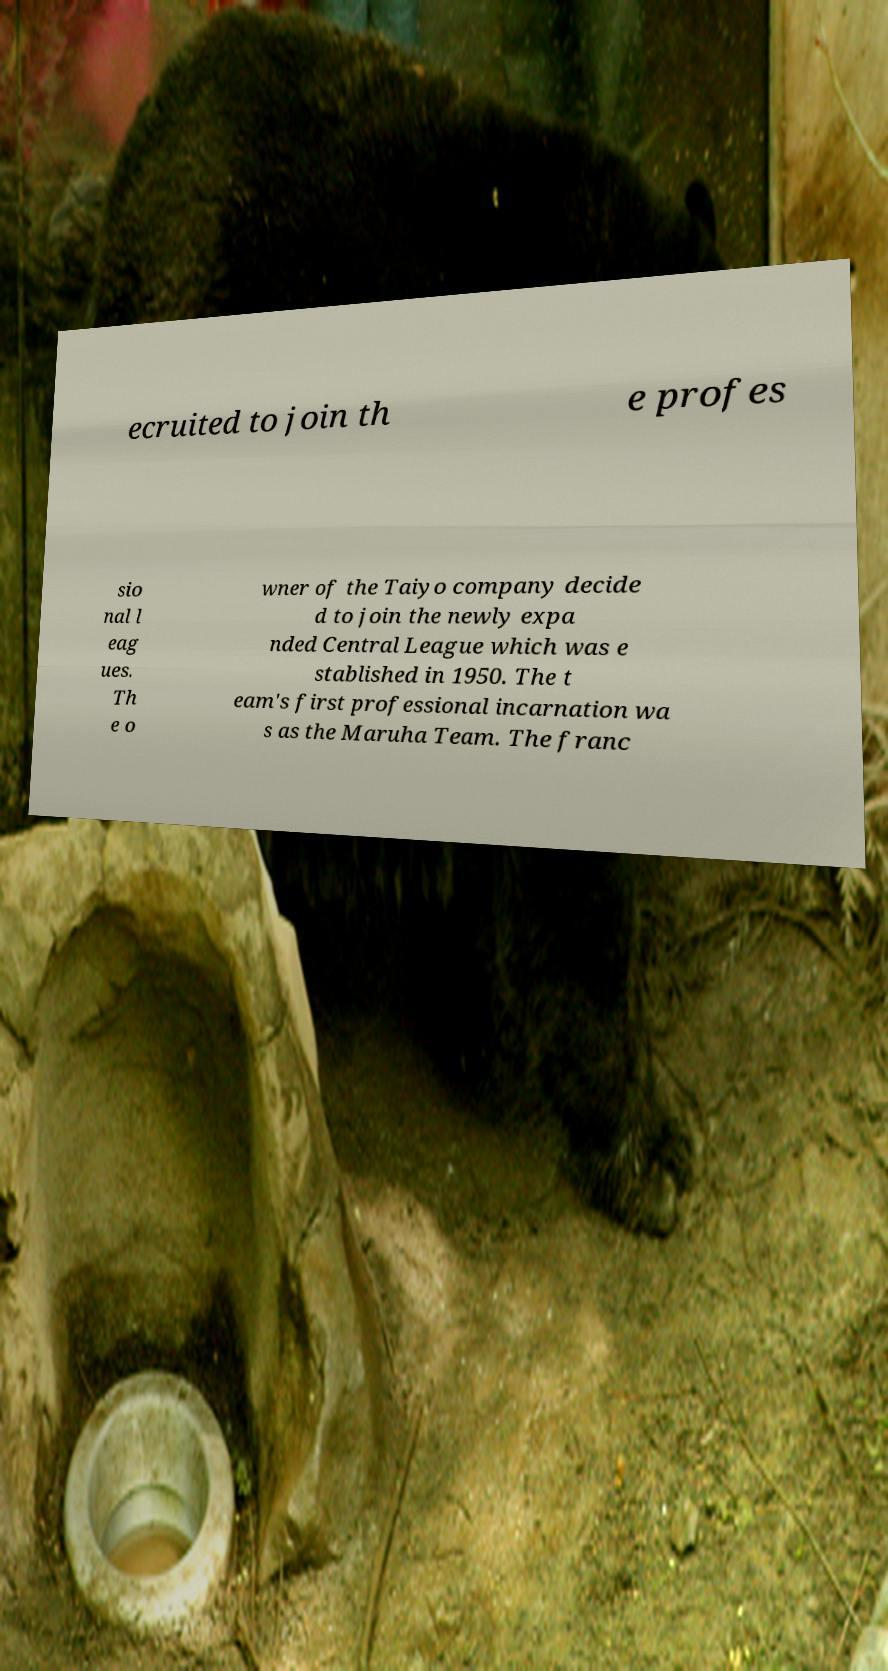Can you read and provide the text displayed in the image?This photo seems to have some interesting text. Can you extract and type it out for me? ecruited to join th e profes sio nal l eag ues. Th e o wner of the Taiyo company decide d to join the newly expa nded Central League which was e stablished in 1950. The t eam's first professional incarnation wa s as the Maruha Team. The franc 